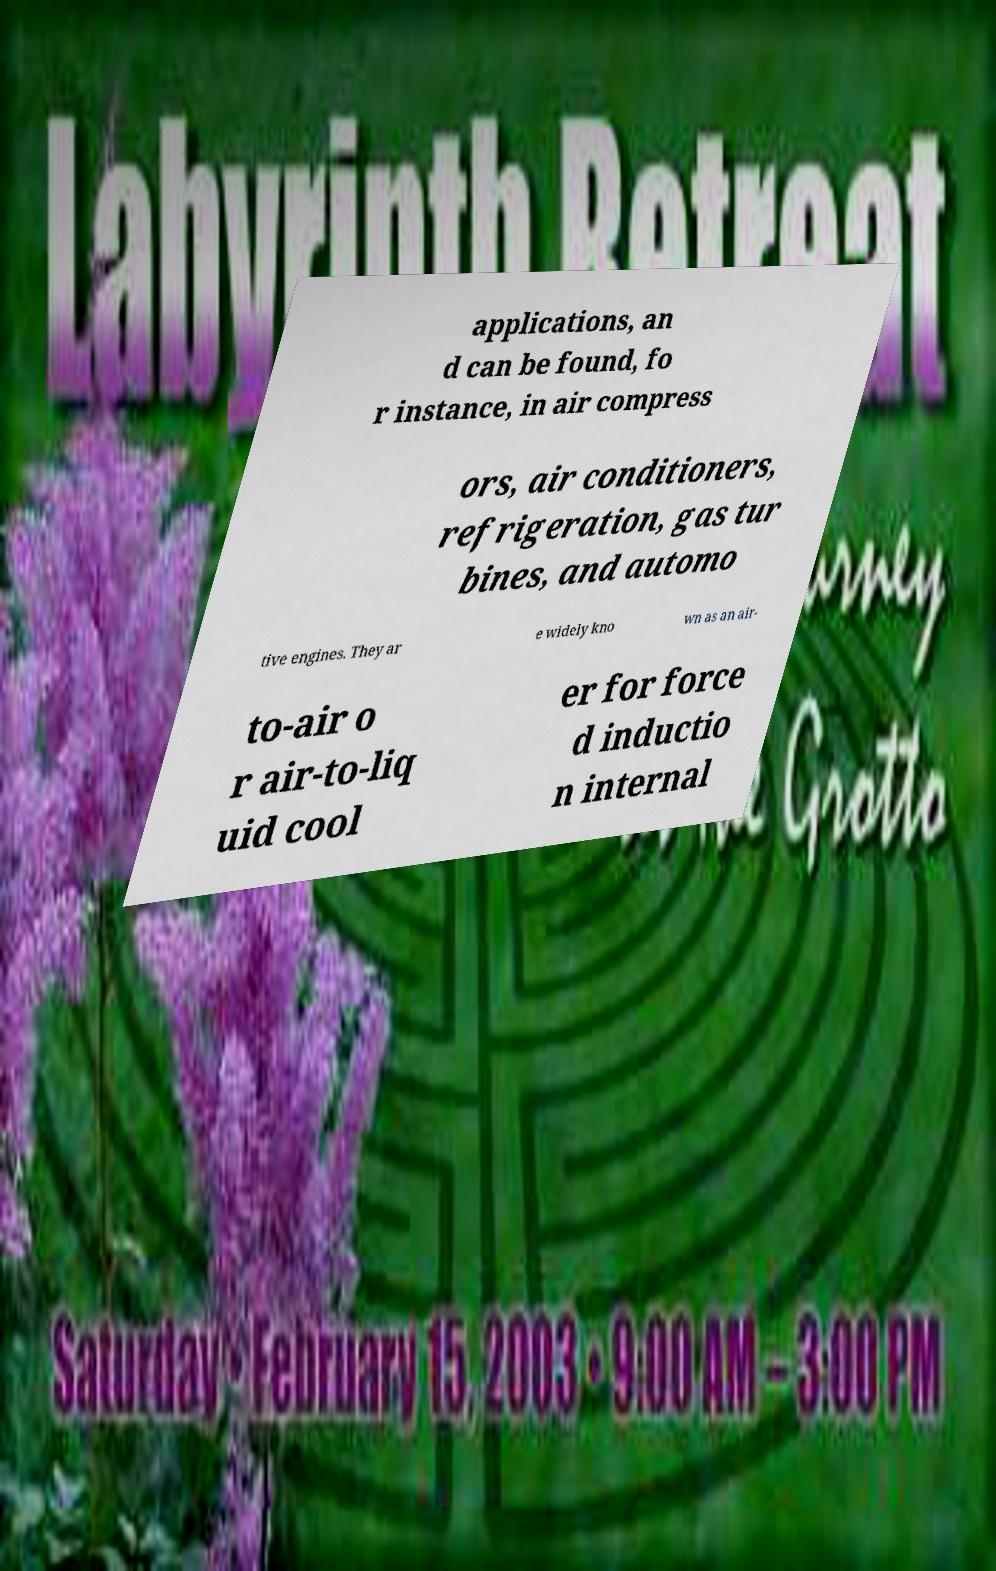What messages or text are displayed in this image? I need them in a readable, typed format. applications, an d can be found, fo r instance, in air compress ors, air conditioners, refrigeration, gas tur bines, and automo tive engines. They ar e widely kno wn as an air- to-air o r air-to-liq uid cool er for force d inductio n internal 